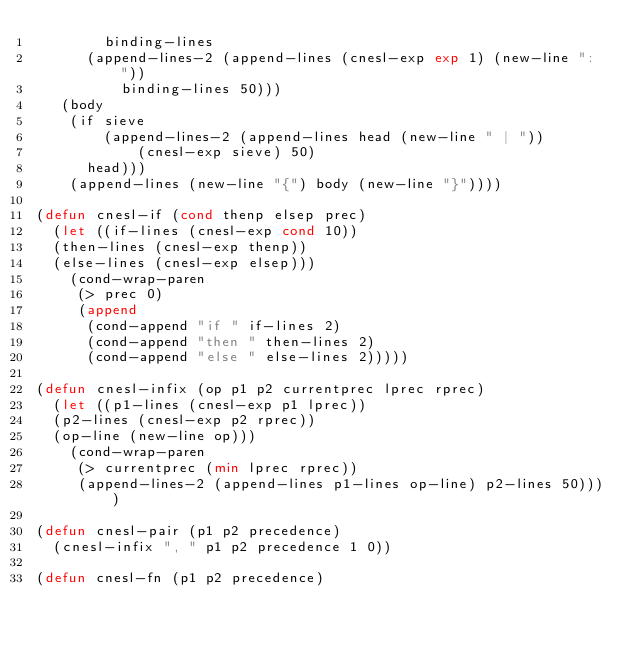Convert code to text. <code><loc_0><loc_0><loc_500><loc_500><_Lisp_>	      binding-lines
	    (append-lines-2 (append-lines (cnesl-exp exp 1) (new-line ": "))
			    binding-lines 50)))
	 (body
	  (if sieve 
	      (append-lines-2 (append-lines head (new-line " | "))
			      (cnesl-exp sieve) 50)
	    head)))
    (append-lines (new-line "{") body (new-line "}"))))

(defun cnesl-if (cond thenp elsep prec)
  (let ((if-lines (cnesl-exp cond 10))
	(then-lines (cnesl-exp thenp))
	(else-lines (cnesl-exp elsep)))
    (cond-wrap-paren 
     (> prec 0)
     (append 
      (cond-append "if " if-lines 2)
      (cond-append "then " then-lines 2)
      (cond-append "else " else-lines 2)))))

(defun cnesl-infix (op p1 p2 currentprec lprec rprec)
  (let ((p1-lines (cnesl-exp p1 lprec))
	(p2-lines (cnesl-exp p2 rprec))
	(op-line (new-line op)))
    (cond-wrap-paren 
     (> currentprec (min lprec rprec))
     (append-lines-2 (append-lines p1-lines op-line) p2-lines 50))))

(defun cnesl-pair (p1 p2 precedence)
  (cnesl-infix ", " p1 p2 precedence 1 0))

(defun cnesl-fn (p1 p2 precedence)</code> 